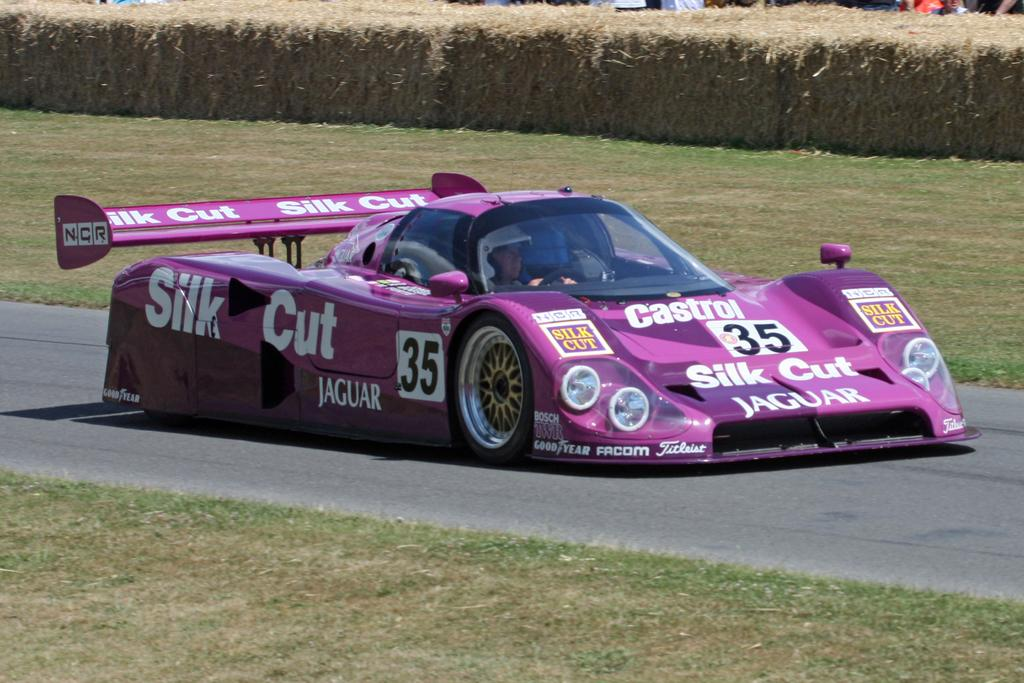What is the person in the image doing? The person in the image is driving a vehicle. Where is the vehicle located? The vehicle is on the road. What can be seen on the vehicle? There is text visible on the vehicle. What type of vegetation is present in the image? There are plants and grass in the image. What type of throat-soothing remedy can be seen in the image? There is no throat-soothing remedy present in the image. Can you tell me how many keys are visible on the vehicle in the image? There is no mention of keys in the provided facts, so it cannot be determined how many keys are visible on the vehicle. 